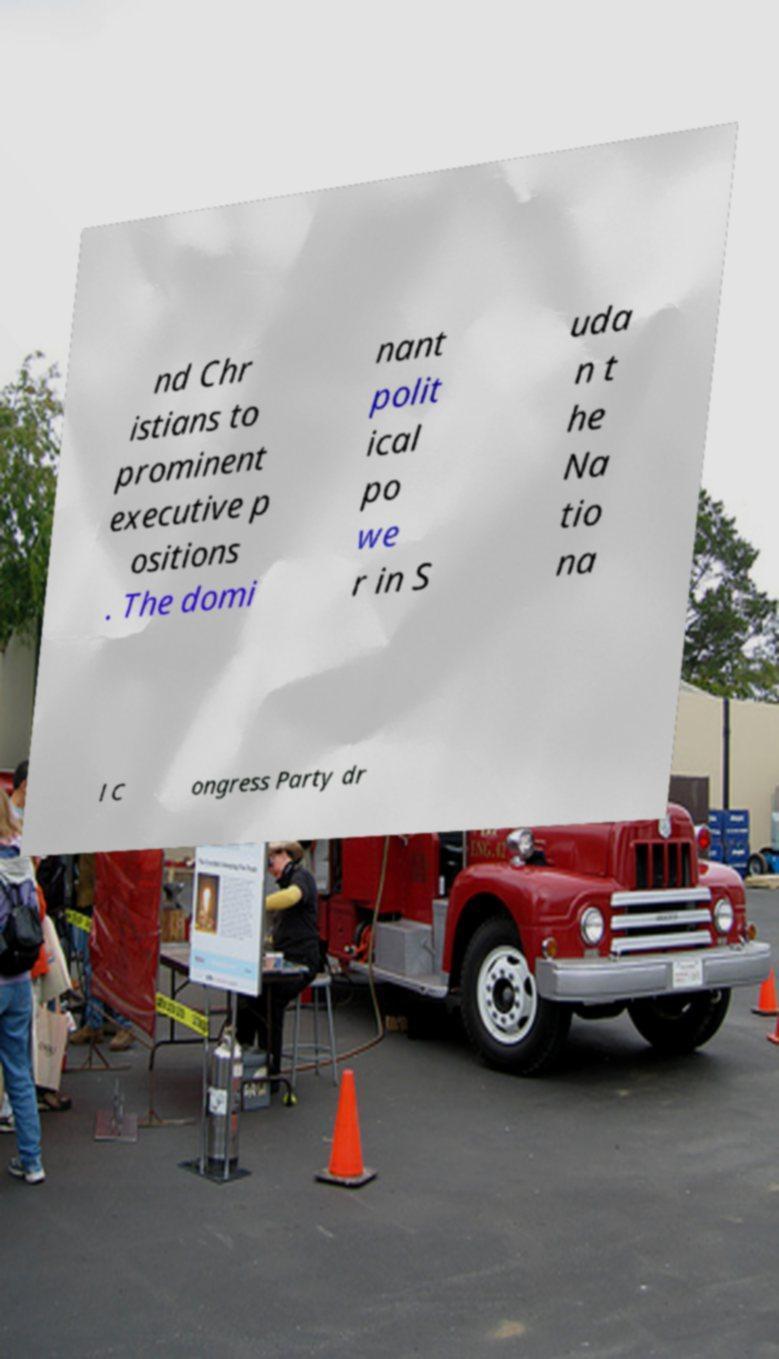Can you read and provide the text displayed in the image?This photo seems to have some interesting text. Can you extract and type it out for me? nd Chr istians to prominent executive p ositions . The domi nant polit ical po we r in S uda n t he Na tio na l C ongress Party dr 